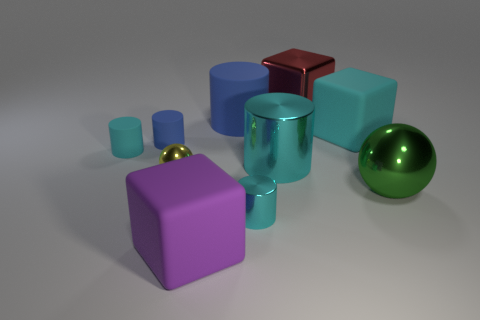The tiny metallic cylinder is what color?
Provide a short and direct response. Cyan. What number of objects are either large green things or tiny cyan matte objects?
Your answer should be very brief. 2. Are there any purple matte things of the same shape as the big red metallic object?
Provide a succinct answer. Yes. Is the color of the matte thing to the right of the big red metal block the same as the large metallic cylinder?
Make the answer very short. Yes. What shape is the cyan rubber thing behind the cyan rubber object left of the large red object?
Make the answer very short. Cube. Is there a red shiny object of the same size as the metal block?
Offer a terse response. No. Are there fewer purple blocks than matte objects?
Your answer should be very brief. Yes. What shape is the blue object in front of the cyan matte object to the right of the cyan shiny object that is in front of the large green thing?
Give a very brief answer. Cylinder. What number of things are big green spheres that are behind the big purple thing or metal objects that are to the left of the red object?
Offer a terse response. 4. Are there any large cyan cylinders to the right of the large purple rubber block?
Your response must be concise. Yes. 